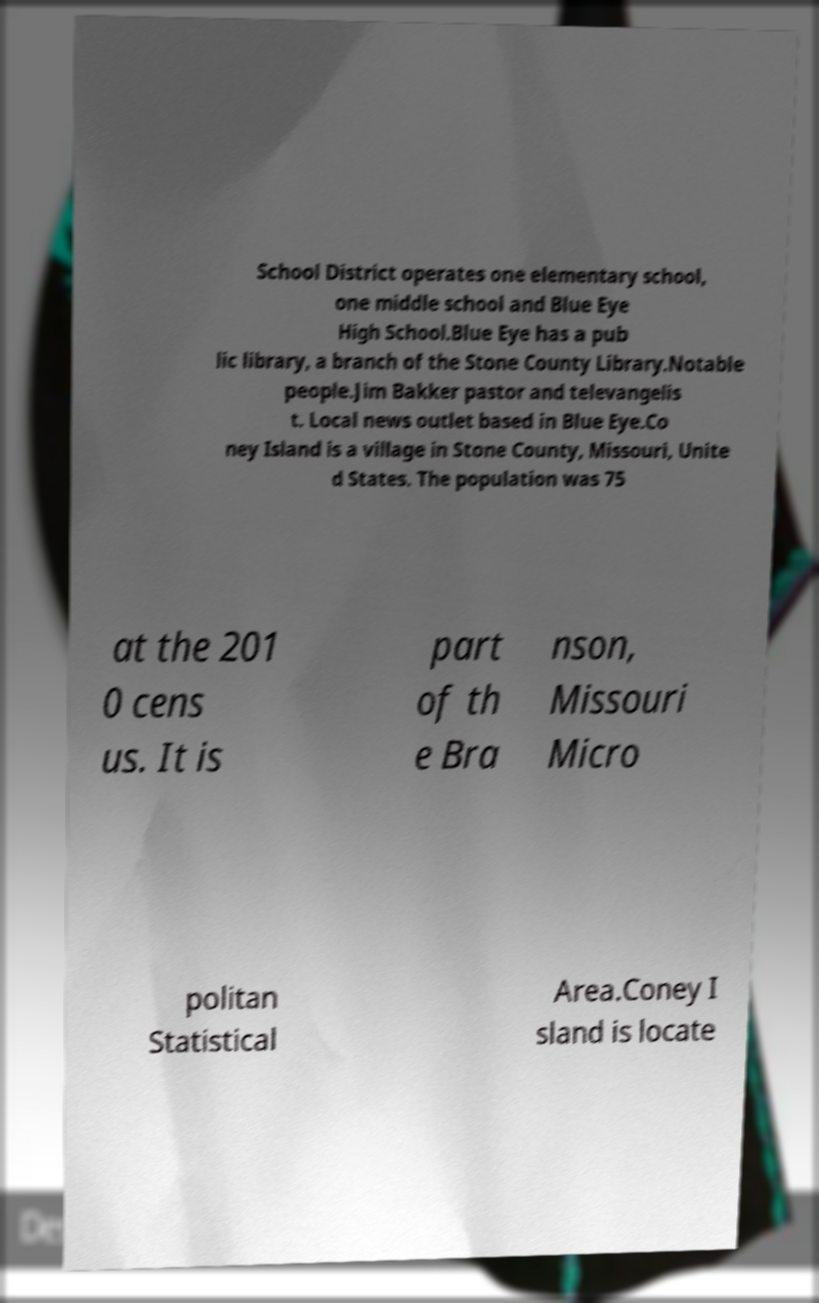Please identify and transcribe the text found in this image. School District operates one elementary school, one middle school and Blue Eye High School.Blue Eye has a pub lic library, a branch of the Stone County Library.Notable people.Jim Bakker pastor and televangelis t. Local news outlet based in Blue Eye.Co ney Island is a village in Stone County, Missouri, Unite d States. The population was 75 at the 201 0 cens us. It is part of th e Bra nson, Missouri Micro politan Statistical Area.Coney I sland is locate 